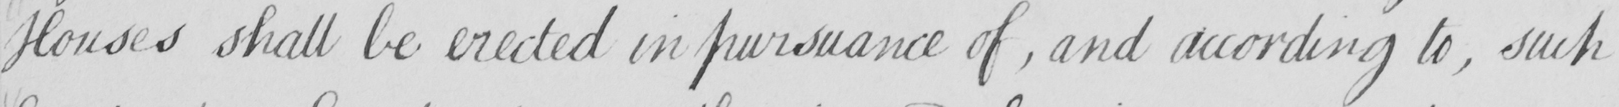What is written in this line of handwriting? Houses shall be erected in pursuance of  , and according to , such 